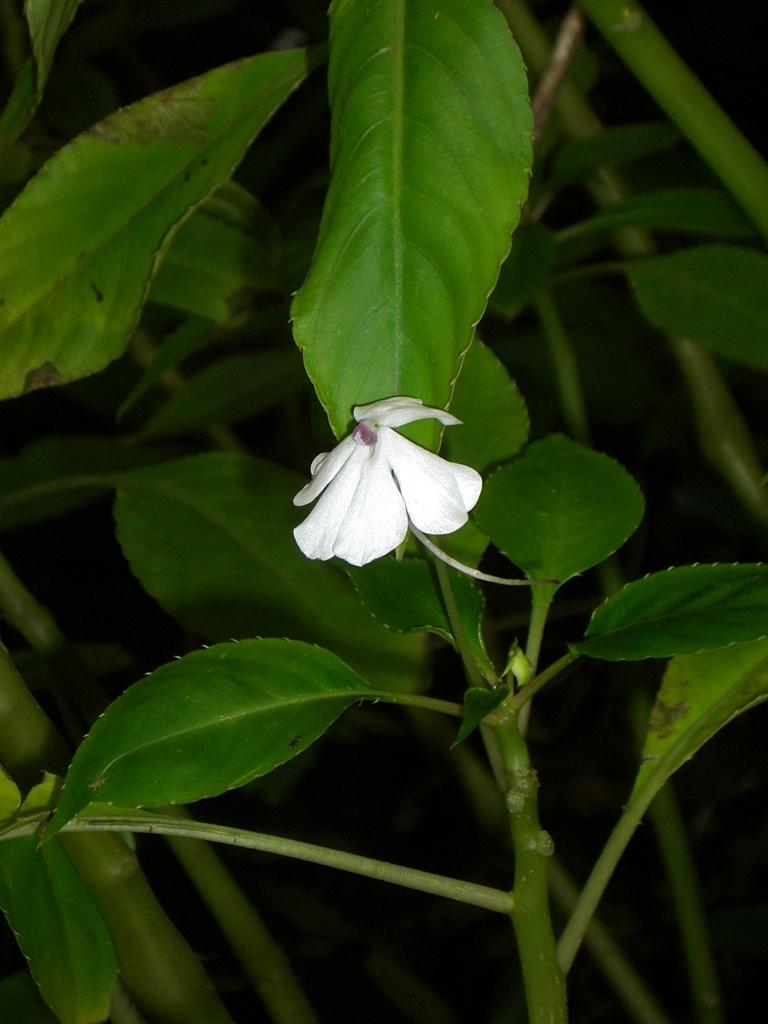What type of living organism can be seen in the image? There is a plant in the image. What is the most prominent feature of the plant in the image? There is a flower at the center of the image. What historical event is depicted in the image? There is no historical event depicted in the image; it features a plant with a flower at the center. What type of thread is used to create the flower in the image? There is no thread present in the image; the flower is a natural part of the plant. 